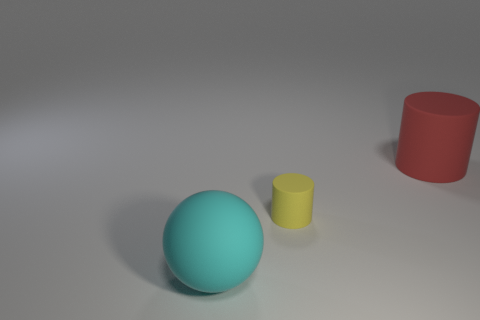What size is the yellow object?
Make the answer very short. Small. Does the big rubber ball have the same color as the tiny cylinder?
Your answer should be compact. No. How big is the cylinder that is in front of the red matte cylinder?
Ensure brevity in your answer.  Small. There is a big thing that is behind the sphere; does it have the same color as the big matte thing to the left of the small object?
Your answer should be very brief. No. What number of other things are there of the same shape as the red object?
Offer a very short reply. 1. Are there an equal number of matte cylinders in front of the big cyan sphere and red rubber cylinders behind the red rubber thing?
Offer a very short reply. Yes. Does the large object that is behind the sphere have the same material as the large cyan object left of the small thing?
Provide a succinct answer. Yes. How many other objects are there of the same size as the rubber sphere?
Your response must be concise. 1. How many things are big cyan balls or large cylinders that are behind the rubber sphere?
Provide a succinct answer. 2. Is the number of yellow objects in front of the tiny cylinder the same as the number of big cyan shiny spheres?
Ensure brevity in your answer.  Yes. 